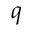<formula> <loc_0><loc_0><loc_500><loc_500>q</formula> 